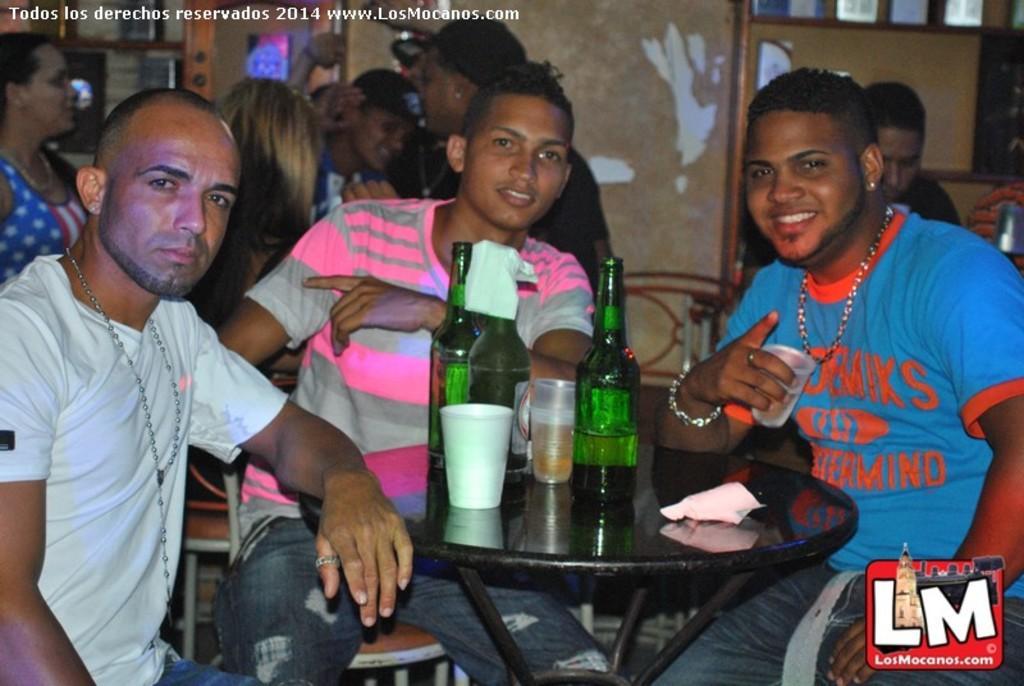In one or two sentences, can you explain what this image depicts? In this picture we can see all the persons sitting on chairs in front of a table and on the table we can see bottles, glasses. On the background we can see and compartments. 